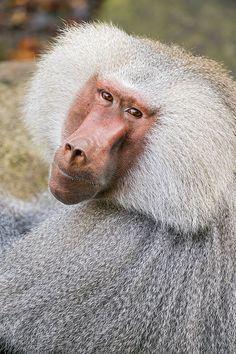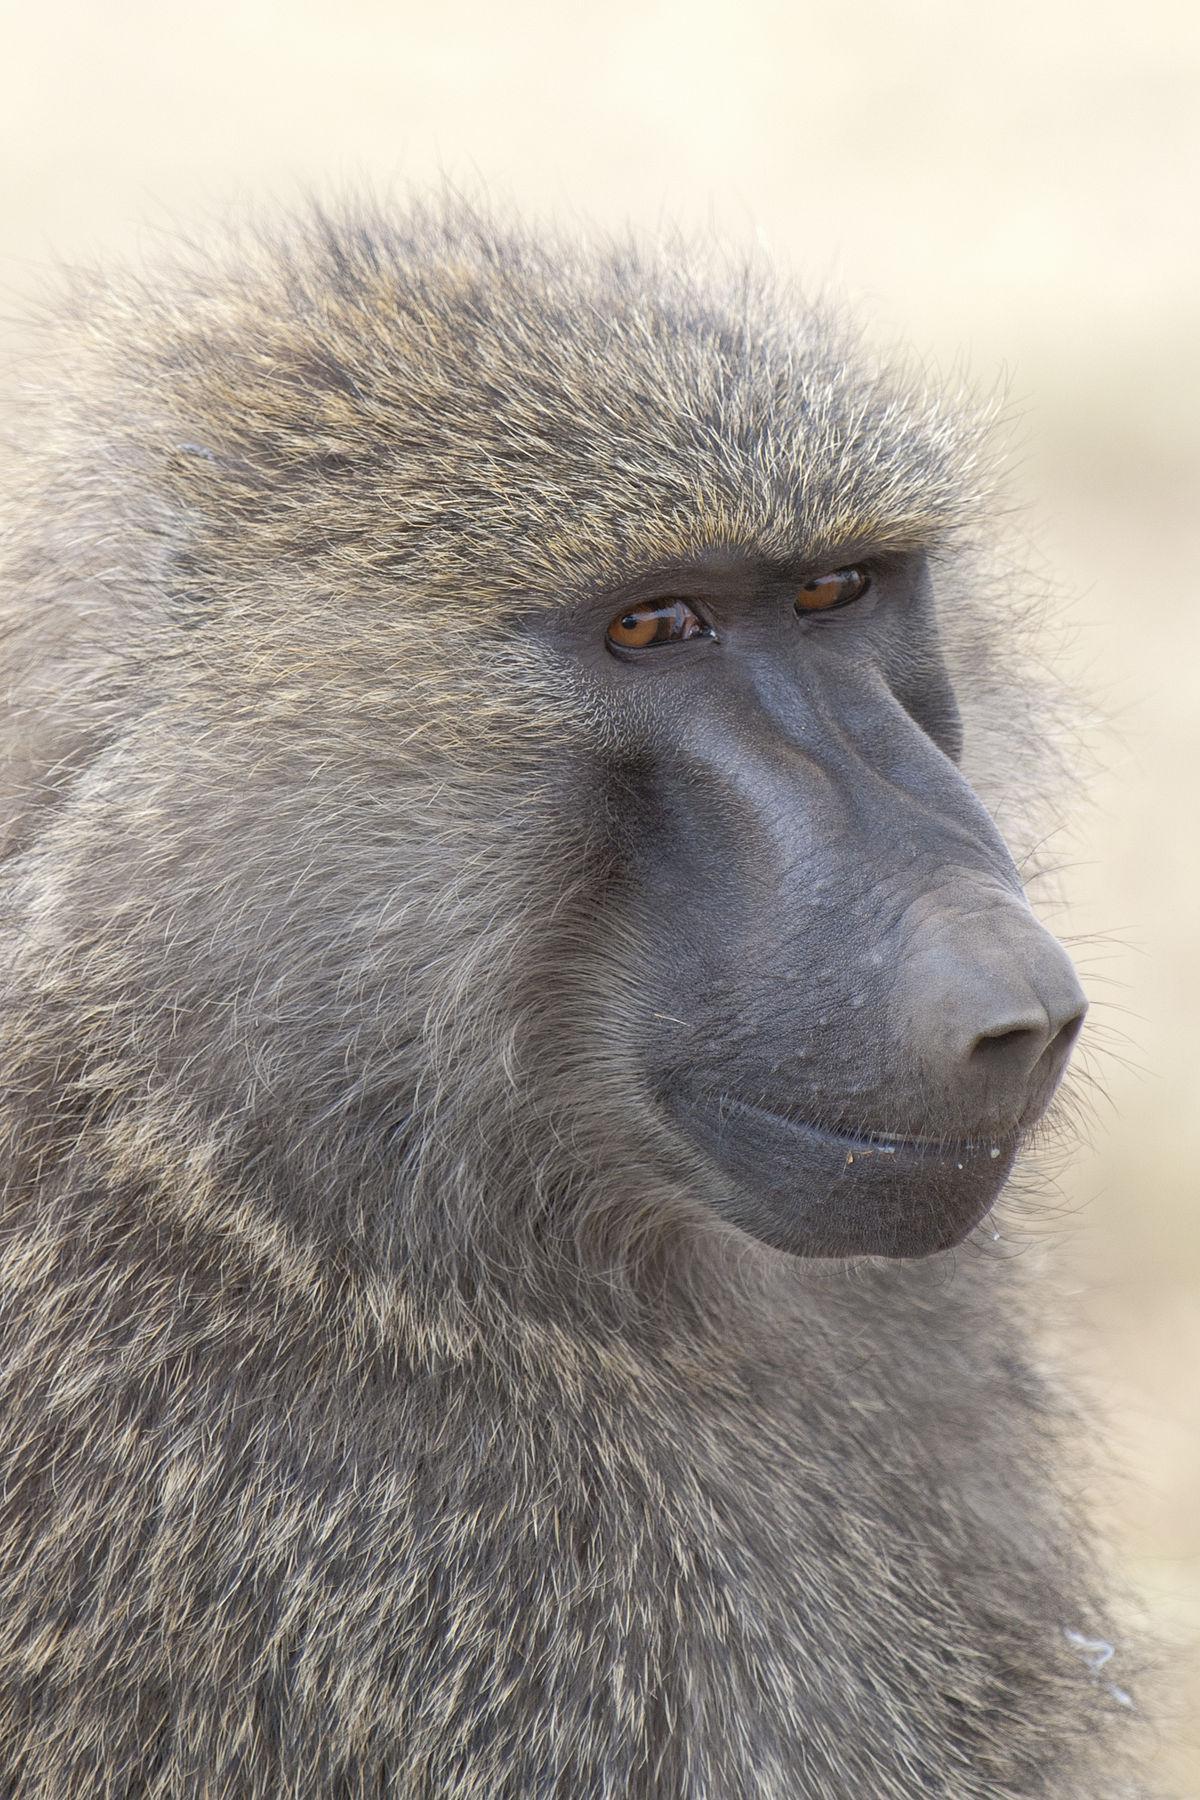The first image is the image on the left, the second image is the image on the right. Assess this claim about the two images: "The primate in the image on the left has greyish whitish hair.". Correct or not? Answer yes or no. Yes. The first image is the image on the left, the second image is the image on the right. Considering the images on both sides, is "An image shows a baboon standing on all fours with part of its bulbous pink hairless rear showing." valid? Answer yes or no. No. 